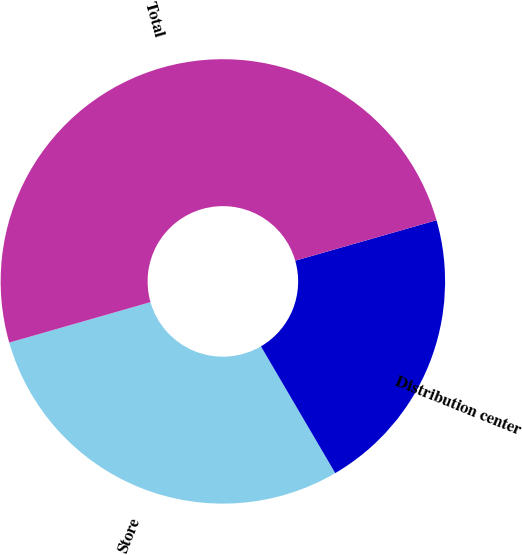<chart> <loc_0><loc_0><loc_500><loc_500><pie_chart><fcel>Store<fcel>Distribution center<fcel>Total<nl><fcel>29.0%<fcel>21.0%<fcel>50.0%<nl></chart> 